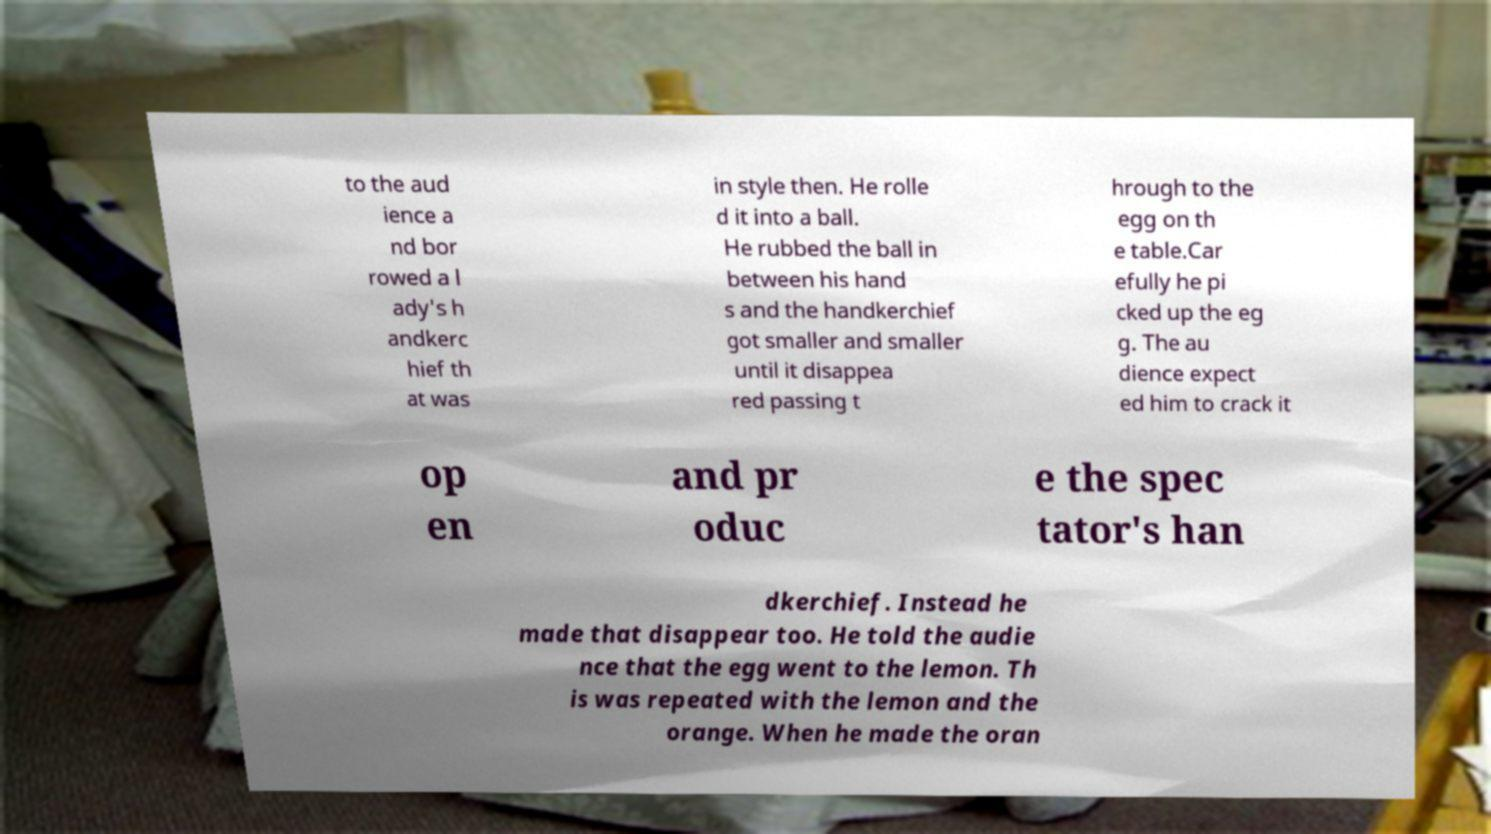Can you accurately transcribe the text from the provided image for me? to the aud ience a nd bor rowed a l ady's h andkerc hief th at was in style then. He rolle d it into a ball. He rubbed the ball in between his hand s and the handkerchief got smaller and smaller until it disappea red passing t hrough to the egg on th e table.Car efully he pi cked up the eg g. The au dience expect ed him to crack it op en and pr oduc e the spec tator's han dkerchief. Instead he made that disappear too. He told the audie nce that the egg went to the lemon. Th is was repeated with the lemon and the orange. When he made the oran 